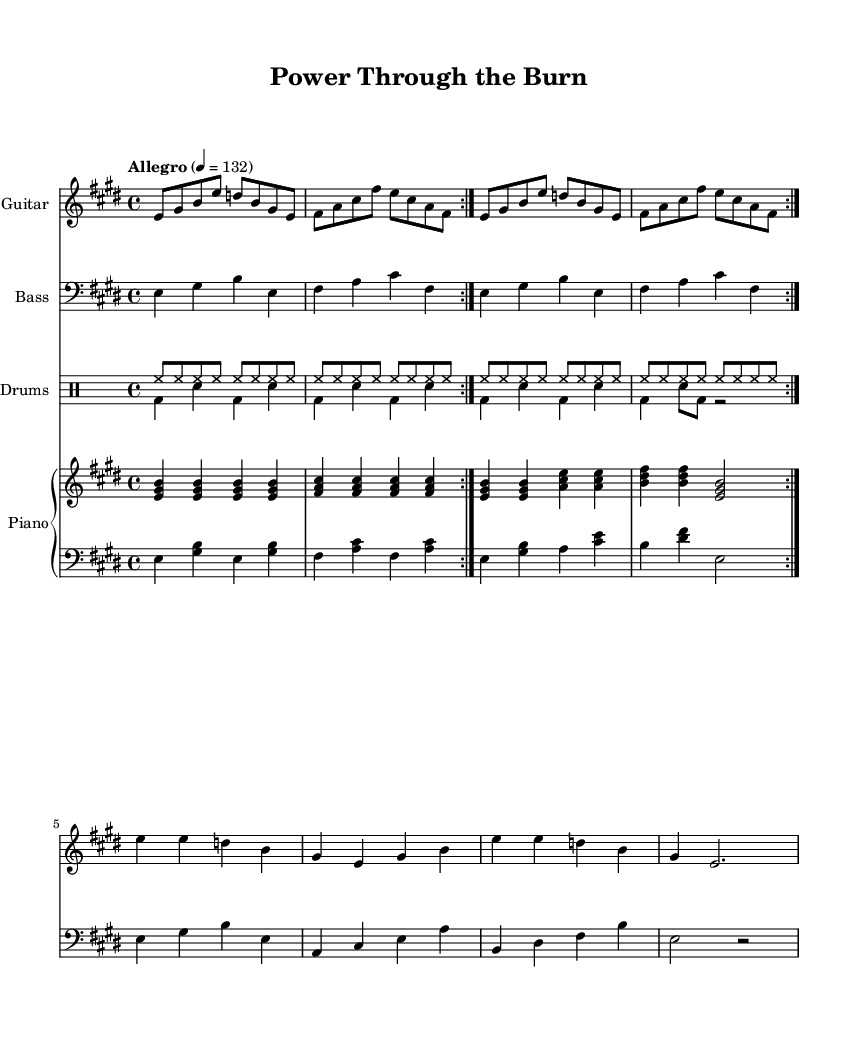What is the key signature of this music? The key signature indicated in the music sheet shows that it has four sharps, which means it is in E major.
Answer: E major What is the time signature of this music? The time signature is indicated at the beginning of the sheet music, showing that the piece is in 4/4 time, meaning there are four beats per measure.
Answer: 4/4 What is the tempo marking of the piece? The tempo marking is given as "Allegro," which indicates a fast and lively pace, quantified in beats per minute as 132.
Answer: 132 How many times is the opening section repeated? The opening section, as marked with "volta," is repeated twice in the music, as indicated by the repeat signs.
Answer: 2 What instruments are included in this arrangement? The arranged music includes guitar, bass, drums, and piano, as indicated by the staff headings for each instrumental part.
Answer: Guitar, Bass, Drums, Piano How many measures are there in the first section of the guitar part? The guitar part, before moving to a different section or a repeat, has a total of eight measures based on the provided music notation.
Answer: 8 